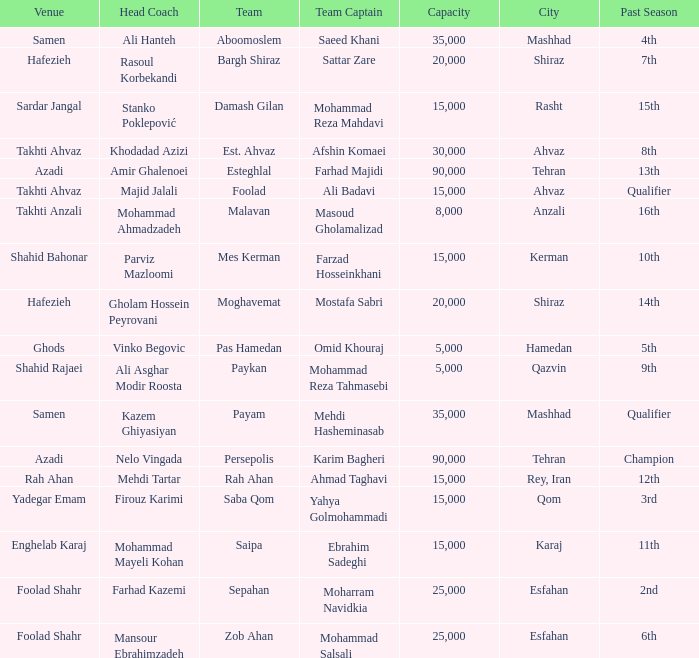What is the Capacity of the Venue of Head Coach Farhad Kazemi? 25000.0. 